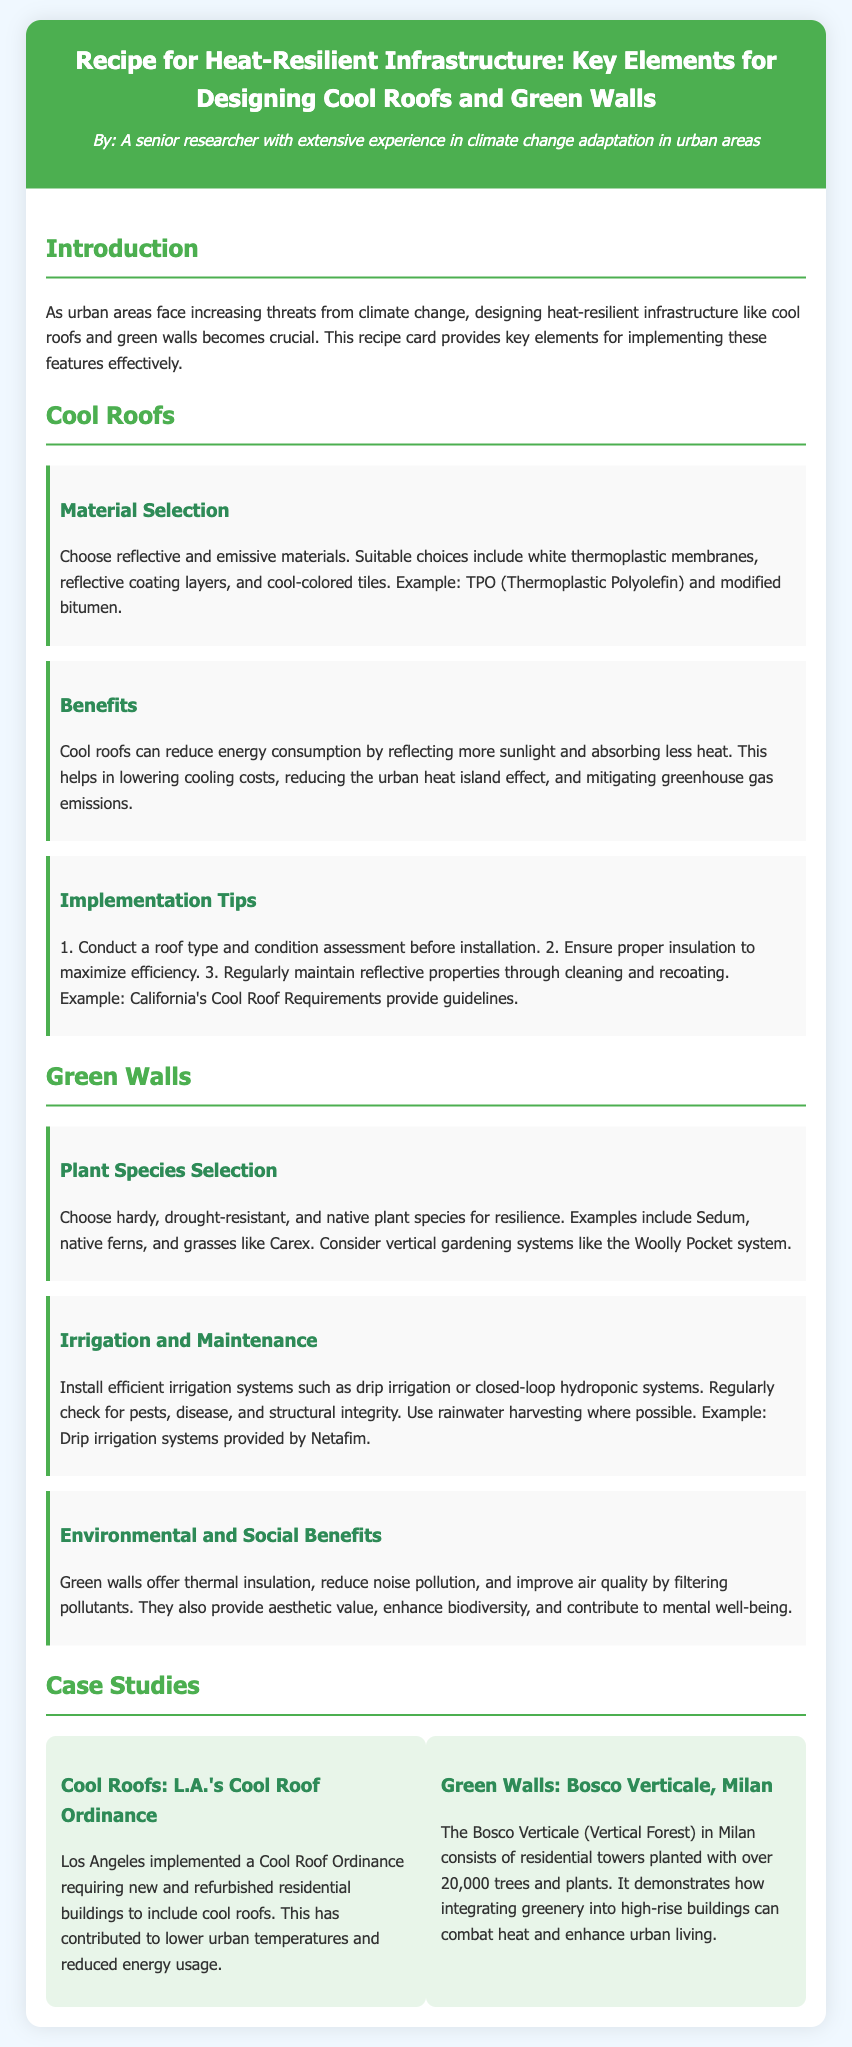What are the key infrastructure types discussed? The document discusses cool roofs and green walls as key infrastructure types for heat-resilient design.
Answer: cool roofs and green walls What material is suggested for cool roofs? The document suggests using white thermoplastic membranes, reflective coating layers, and cool-colored tiles for cool roofs.
Answer: white thermoplastic membranes Which plant species are recommended for green walls? The document recommends hardy, drought-resistant, and native plant species such as Sedum and native ferns for green walls.
Answer: Sedum What benefits do cool roofs provide? Cool roofs reduce energy consumption, cooling costs, and mitigate greenhouse gas emissions as mentioned in the document.
Answer: reduce energy consumption What is the example urban case study for cool roofs? The document cites Los Angeles's Cool Roof Ordinance as an example of a case study for cool roofs.
Answer: L.A.'s Cool Roof Ordinance How many trees and plants are in Bosco Verticale? The Bosco Verticale in Milan has over 20,000 trees and plants planted in its residential towers, as stated in the document.
Answer: over 20,000 What type of irrigation system is recommended for green walls? The document recommends drip irrigation for efficient irrigation systems for green walls.
Answer: drip irrigation What are the environmental benefits of green walls? Green walls offer thermal insulation, reduce noise pollution, and improve air quality, according to the document.
Answer: thermal insulation What does the document suggest for maintaining cool roofs? Regular maintenance includes cleaning and recoating to maximize the reflective properties of cool roofs, as mentioned in the implementation tips.
Answer: cleaning and recoating 